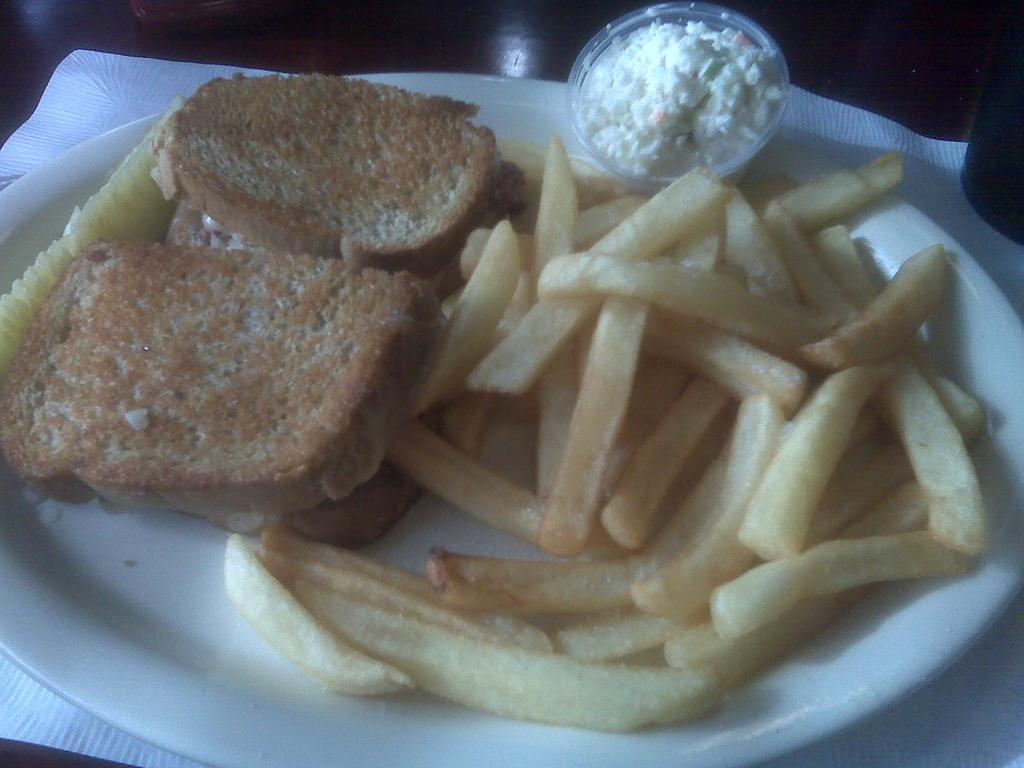What is the main subject of the image? The main subject of the image is food on a plate. Where is the plate located in the image? The plate is in the center of the image. What type of answer can be seen written on the caption of the image? There is no caption present in the image, so no answer can be seen written on it. 